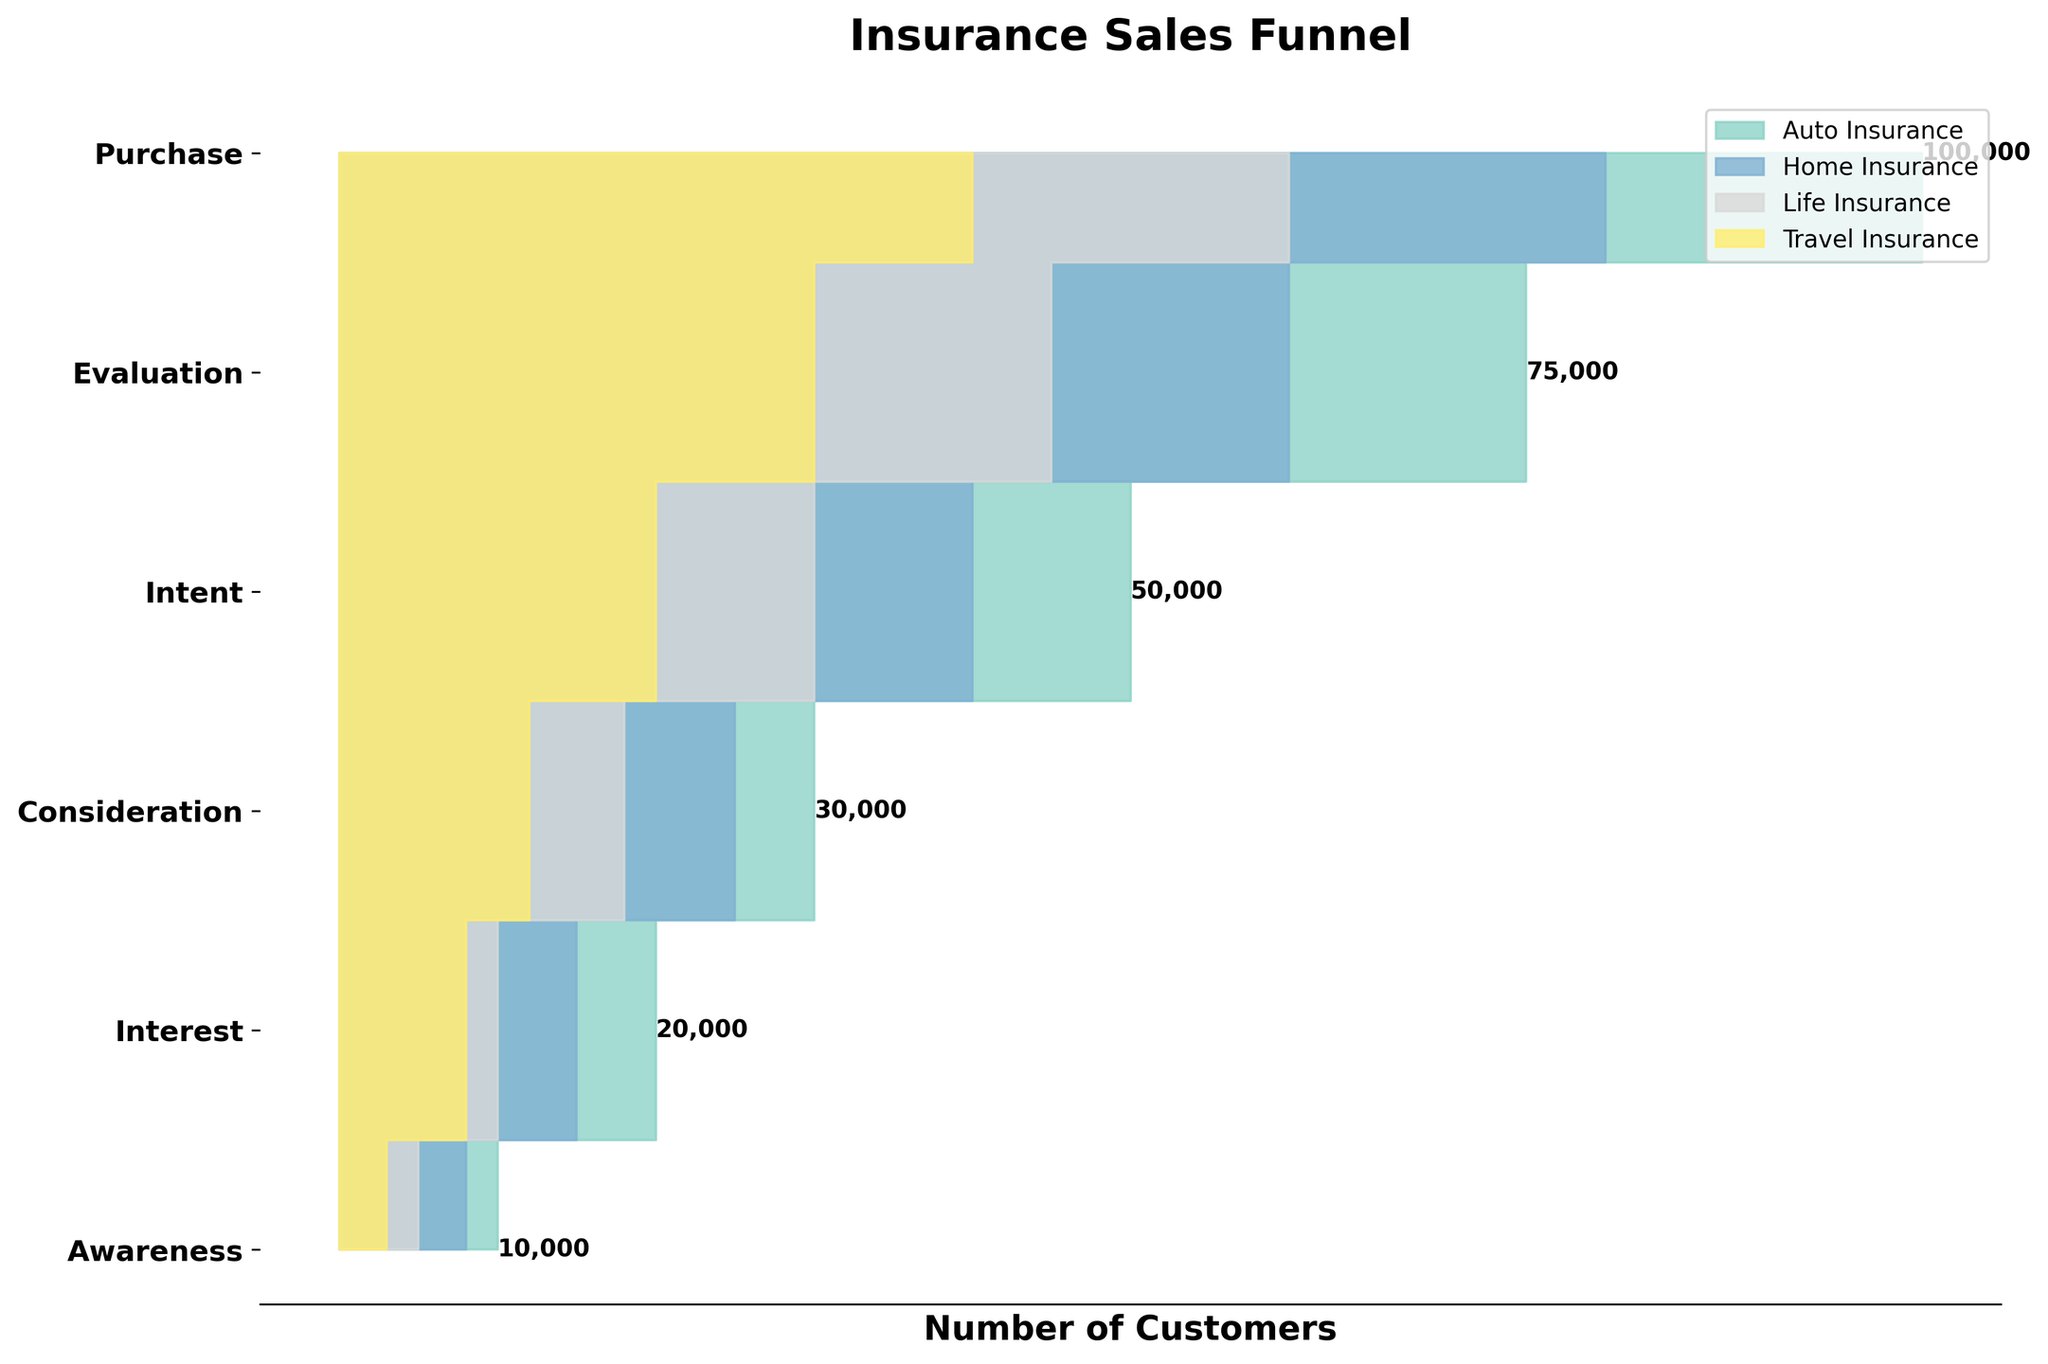What is the title of the figure? The title of the figure can be found at the top. It is typically displayed in bold and larger font size compared to other text on the chart.
Answer: Insurance Sales Funnel How many stages are there in the funnel for each insurance policy? The number of stages can be determined by counting the distinct labels on the y-axis from top to bottom.
Answer: 6 What is the total number of customers who showed Interest in both Auto and Home Insurance? Sum the number of customers under the Interest stage for Auto Insurance and Home Insurance, i.e., 75,000 (Auto) + 60,000 (Home).
Answer: 135,000 Which insurance policy has the most significant drop in the number of customers from Awareness to Interest? Calculate the difference between Awareness and Interest for each policy. Auto: 100,000 - 75,000 = 25,000; Home: 80,000 - 60,000 = 20,000; Life: 60,000 - 45,000 = 15,000; Travel: 40,000 - 30,000 = 10,000. Compare all differences.
Answer: Auto Insurance Which stage in the funnel has the smallest number of Life Insurance customers? Identify the smallest value among all stages under Life Insurance column. The values are: Awareness: 60,000; Interest: 45,000; Consideration: 30,000; Intent: 18,000; Evaluation: 10,000; Purchase: 5,000.
Answer: Purchase What is the total number of customers who reached the Purchase stage across all insurance policies? Sum the number of customers under the Purchase stage for all policies: Auto (10,000) + Home (8,000) + Life (5,000) + Travel (3,000).
Answer: 26,000 Which insurance policy has the most customers at the Evaluation stage? Compare the number of customers among all policies at the Evaluation stage. Auto: 20,000; Home: 15,000; Life: 10,000; Travel: 8,000.
Answer: Auto Insurance What is the ratio of Intent to Awareness for Travel Insurance? Divide the number of customers at the Intent stage by the number of customers at the Awareness stage for Travel Insurance. 12,000 (Intent) / 40,000 (Awareness).
Answer: 0.3 How do the number of customers at the Consideration stage for Home and Life Insurances compare? Look at the Consideration stage numbers for Home and Life Insurances: Home (40,000) and Life (30,000). Determine the difference by subtraction: 40,000 - 30,000.
Answer: Home Insurance has 10,000 more Which insurance policy's Purchase stage has the highest conversion rate from their Intent stage? Calculate the conversion rate (Purchase/Intent) for each policy. Auto: 10,000/30,000 = 0.33, Home: 8,000/25,000 = 0.32, Life: 5,000/18,000 = 0.28, Travel: 3,000/12,000 = 0.25. Compare the rates.
Answer: Auto Insurance 